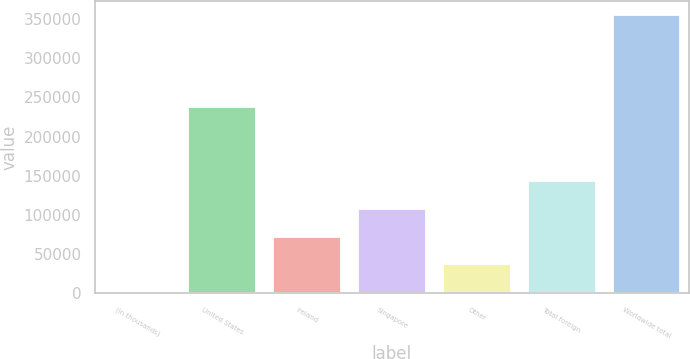Convert chart to OTSL. <chart><loc_0><loc_0><loc_500><loc_500><bar_chart><fcel>(In thousands)<fcel>United States<fcel>Ireland<fcel>Singapore<fcel>Other<fcel>Total foreign<fcel>Worldwide total<nl><fcel>2014<fcel>237229<fcel>72629<fcel>107936<fcel>37321.5<fcel>143244<fcel>355089<nl></chart> 